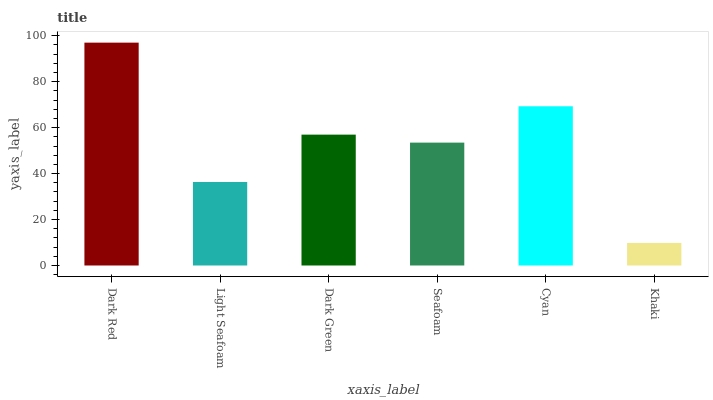Is Khaki the minimum?
Answer yes or no. Yes. Is Dark Red the maximum?
Answer yes or no. Yes. Is Light Seafoam the minimum?
Answer yes or no. No. Is Light Seafoam the maximum?
Answer yes or no. No. Is Dark Red greater than Light Seafoam?
Answer yes or no. Yes. Is Light Seafoam less than Dark Red?
Answer yes or no. Yes. Is Light Seafoam greater than Dark Red?
Answer yes or no. No. Is Dark Red less than Light Seafoam?
Answer yes or no. No. Is Dark Green the high median?
Answer yes or no. Yes. Is Seafoam the low median?
Answer yes or no. Yes. Is Cyan the high median?
Answer yes or no. No. Is Light Seafoam the low median?
Answer yes or no. No. 